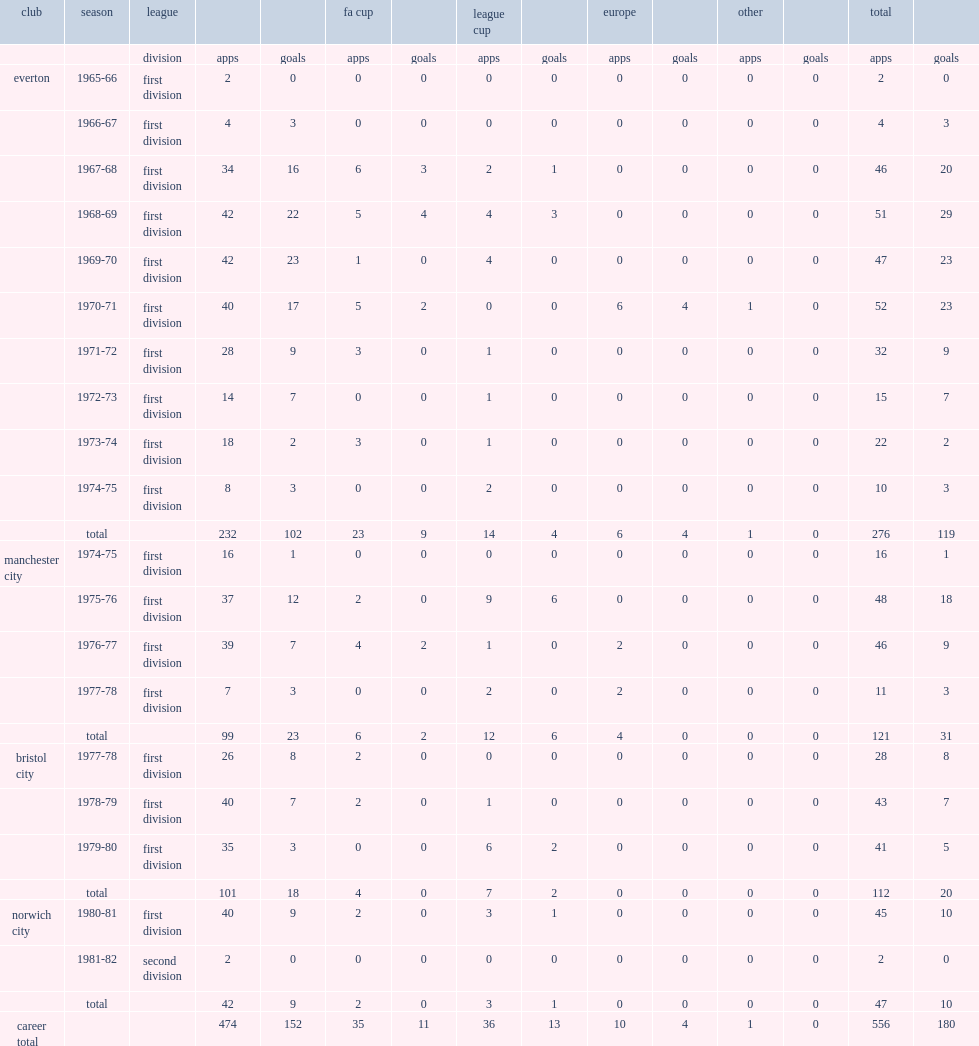Can you parse all the data within this table? {'header': ['club', 'season', 'league', '', '', 'fa cup', '', 'league cup', '', 'europe', '', 'other', '', 'total', ''], 'rows': [['', '', 'division', 'apps', 'goals', 'apps', 'goals', 'apps', 'goals', 'apps', 'goals', 'apps', 'goals', 'apps', 'goals'], ['everton', '1965-66', 'first division', '2', '0', '0', '0', '0', '0', '0', '0', '0', '0', '2', '0'], ['', '1966-67', 'first division', '4', '3', '0', '0', '0', '0', '0', '0', '0', '0', '4', '3'], ['', '1967-68', 'first division', '34', '16', '6', '3', '2', '1', '0', '0', '0', '0', '46', '20'], ['', '1968-69', 'first division', '42', '22', '5', '4', '4', '3', '0', '0', '0', '0', '51', '29'], ['', '1969-70', 'first division', '42', '23', '1', '0', '4', '0', '0', '0', '0', '0', '47', '23'], ['', '1970-71', 'first division', '40', '17', '5', '2', '0', '0', '6', '4', '1', '0', '52', '23'], ['', '1971-72', 'first division', '28', '9', '3', '0', '1', '0', '0', '0', '0', '0', '32', '9'], ['', '1972-73', 'first division', '14', '7', '0', '0', '1', '0', '0', '0', '0', '0', '15', '7'], ['', '1973-74', 'first division', '18', '2', '3', '0', '1', '0', '0', '0', '0', '0', '22', '2'], ['', '1974-75', 'first division', '8', '3', '0', '0', '2', '0', '0', '0', '0', '0', '10', '3'], ['', 'total', '', '232', '102', '23', '9', '14', '4', '6', '4', '1', '0', '276', '119'], ['manchester city', '1974-75', 'first division', '16', '1', '0', '0', '0', '0', '0', '0', '0', '0', '16', '1'], ['', '1975-76', 'first division', '37', '12', '2', '0', '9', '6', '0', '0', '0', '0', '48', '18'], ['', '1976-77', 'first division', '39', '7', '4', '2', '1', '0', '2', '0', '0', '0', '46', '9'], ['', '1977-78', 'first division', '7', '3', '0', '0', '2', '0', '2', '0', '0', '0', '11', '3'], ['', 'total', '', '99', '23', '6', '2', '12', '6', '4', '0', '0', '0', '121', '31'], ['bristol city', '1977-78', 'first division', '26', '8', '2', '0', '0', '0', '0', '0', '0', '0', '28', '8'], ['', '1978-79', 'first division', '40', '7', '2', '0', '1', '0', '0', '0', '0', '0', '43', '7'], ['', '1979-80', 'first division', '35', '3', '0', '0', '6', '2', '0', '0', '0', '0', '41', '5'], ['', 'total', '', '101', '18', '4', '0', '7', '2', '0', '0', '0', '0', '112', '20'], ['norwich city', '1980-81', 'first division', '40', '9', '2', '0', '3', '1', '0', '0', '0', '0', '45', '10'], ['', '1981-82', 'second division', '2', '0', '0', '0', '0', '0', '0', '0', '0', '0', '2', '0'], ['', 'total', '', '42', '9', '2', '0', '3', '1', '0', '0', '0', '0', '47', '10'], ['career total', '', '', '474', '152', '35', '11', '36', '13', '10', '4', '1', '0', '556', '180']]} How many goals did joe royle score for everton? 119.0. 